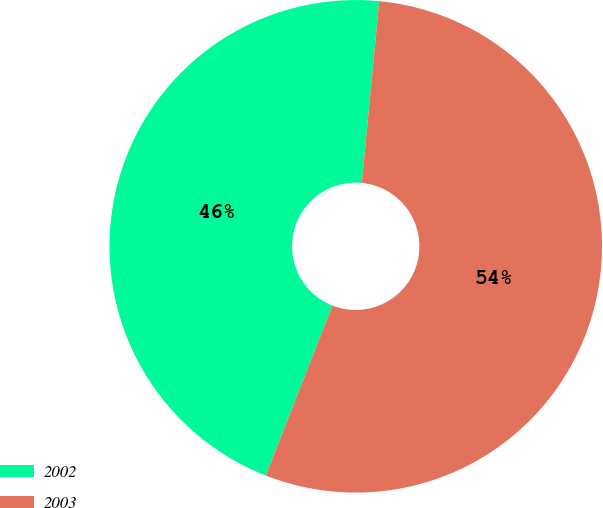<chart> <loc_0><loc_0><loc_500><loc_500><pie_chart><fcel>2002<fcel>2003<nl><fcel>45.57%<fcel>54.43%<nl></chart> 